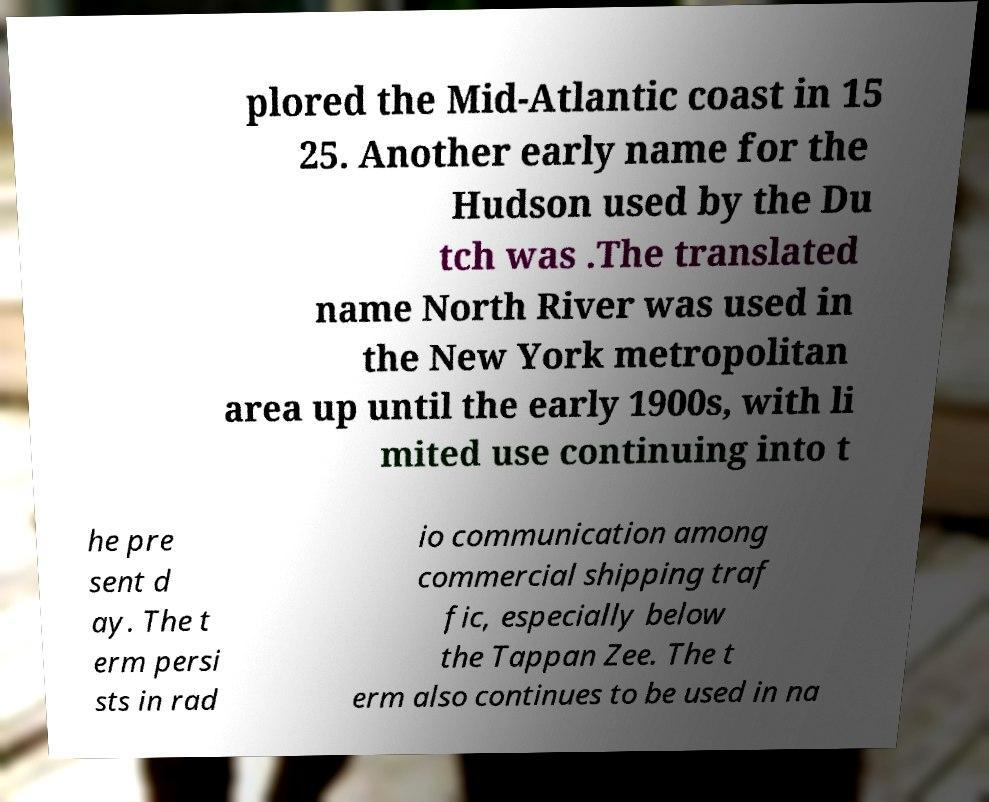There's text embedded in this image that I need extracted. Can you transcribe it verbatim? plored the Mid-Atlantic coast in 15 25. Another early name for the Hudson used by the Du tch was .The translated name North River was used in the New York metropolitan area up until the early 1900s, with li mited use continuing into t he pre sent d ay. The t erm persi sts in rad io communication among commercial shipping traf fic, especially below the Tappan Zee. The t erm also continues to be used in na 